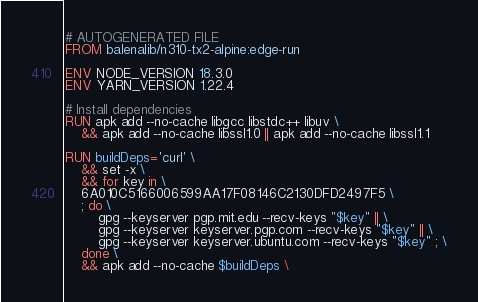<code> <loc_0><loc_0><loc_500><loc_500><_Dockerfile_># AUTOGENERATED FILE
FROM balenalib/n310-tx2-alpine:edge-run

ENV NODE_VERSION 18.3.0
ENV YARN_VERSION 1.22.4

# Install dependencies
RUN apk add --no-cache libgcc libstdc++ libuv \
	&& apk add --no-cache libssl1.0 || apk add --no-cache libssl1.1

RUN buildDeps='curl' \
	&& set -x \
	&& for key in \
	6A010C5166006599AA17F08146C2130DFD2497F5 \
	; do \
		gpg --keyserver pgp.mit.edu --recv-keys "$key" || \
		gpg --keyserver keyserver.pgp.com --recv-keys "$key" || \
		gpg --keyserver keyserver.ubuntu.com --recv-keys "$key" ; \
	done \
	&& apk add --no-cache $buildDeps \</code> 